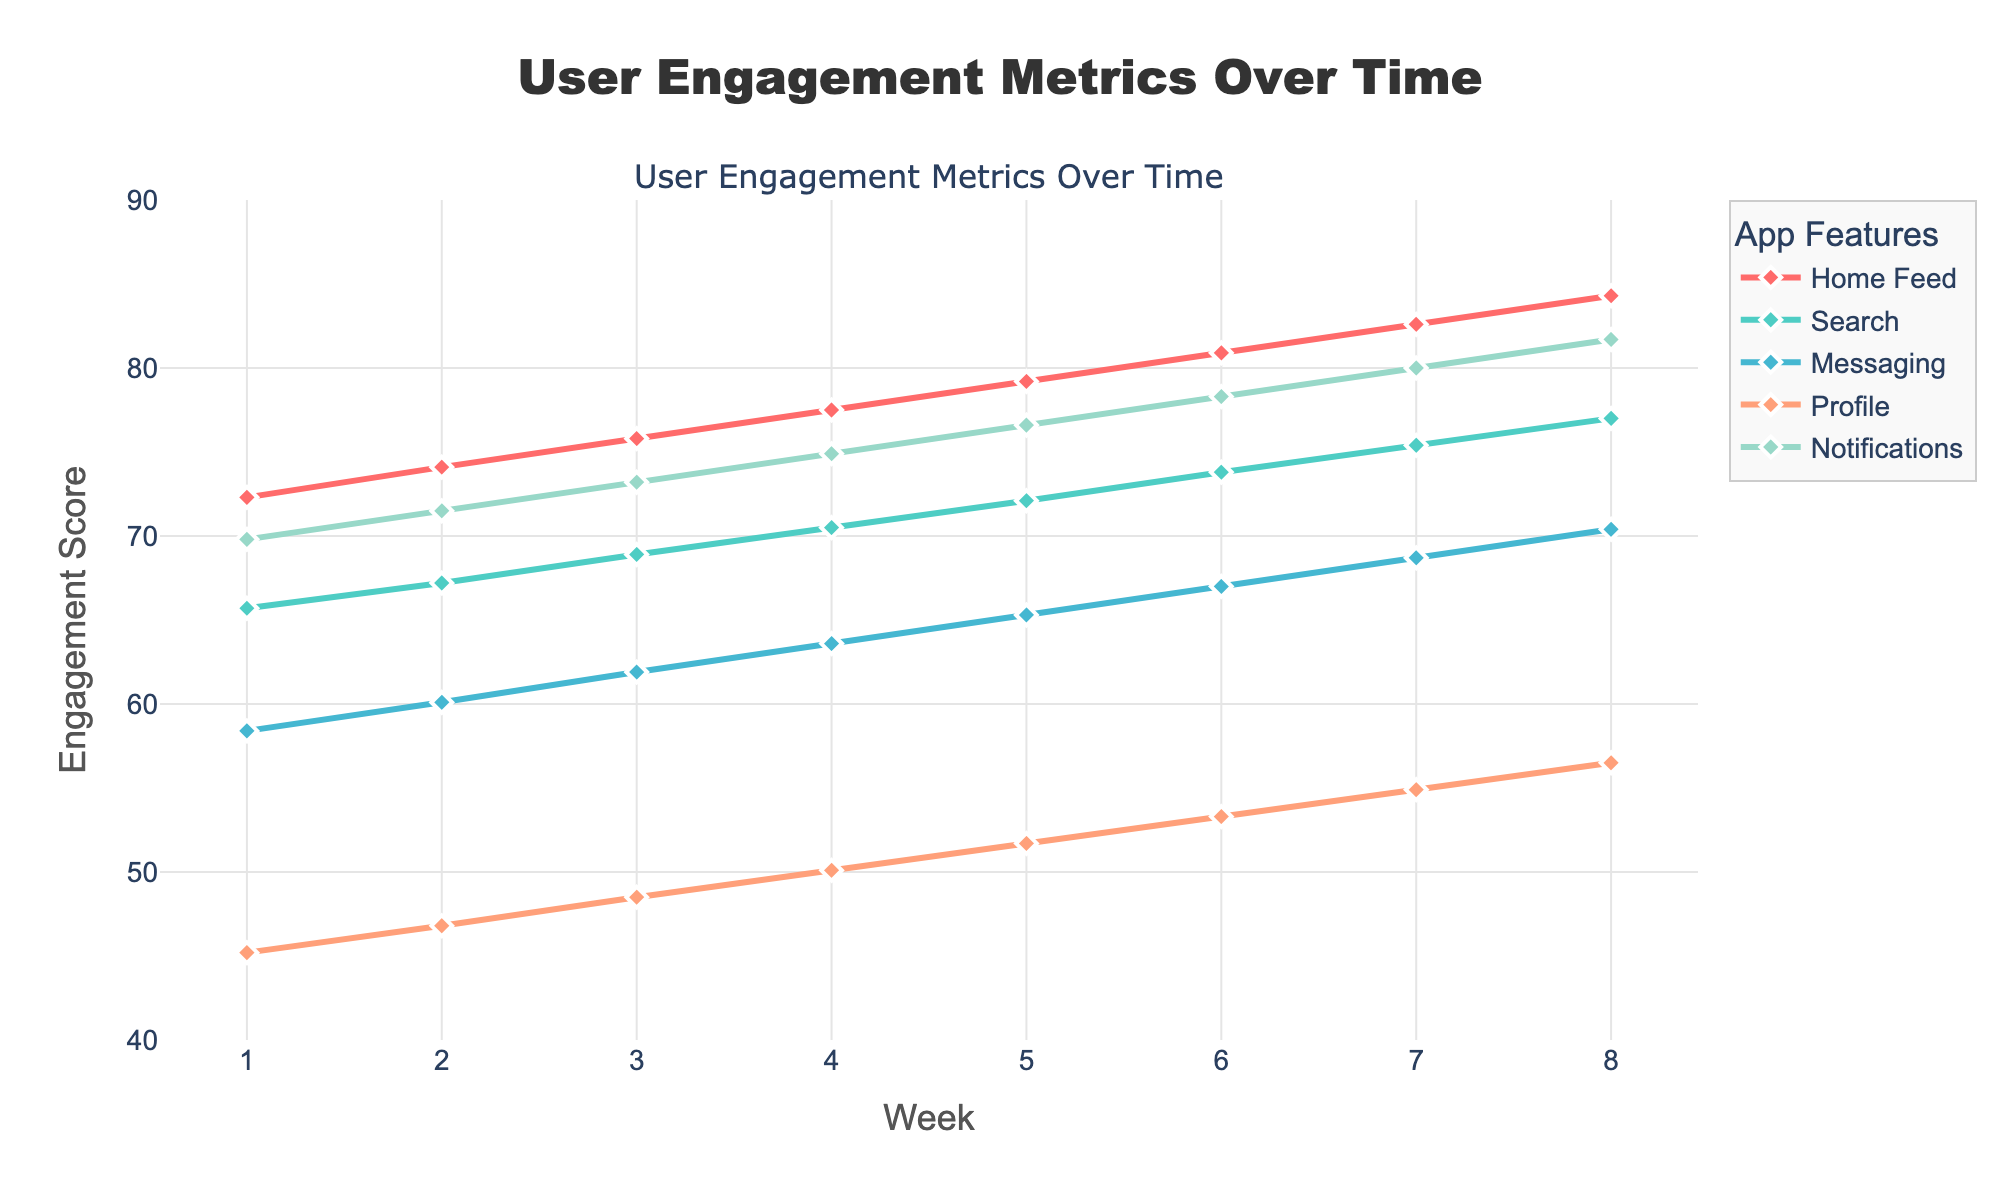Which feature had the highest engagement score at week 4? Locate the engagement scores of all features at week 4: Home Feed (77.5), Search (70.5), Messaging (63.6), Profile (50.1), Notifications (74.9). The highest is 77.5 for Home Feed.
Answer: Home Feed Which feature showed the greatest overall increase in engagement score from week 1 to week 8? Calculate the increase for each feature from week 1 to week 8: Home Feed (84.3 - 72.3 = 12.0), Search (77.0 - 65.7 = 11.3), Messaging (70.4 - 58.4 = 12.0), Profile (56.5 - 45.2 = 11.3), Notifications (81.7-69.8 = 11.9). The greatest increase is for Home Feed and Messaging (12.0).
Answer: Home Feed, Messaging What is the average engagement score for the 'Search' feature over the 8-week period? Sum the engagement scores for Search over the 8 weeks: (65.7 + 67.2 + 68.9 + 70.5 + 72.1 + 73.8 + 75.4 + 77.0) = 570.6. Then, divide by 8 to get the average: 570.6 / 8 = 71.325.
Answer: 71.325 Compare the engagement scores of 'Notifications' and 'Profile' at week 6. Which one had a higher score? Look at the engagement scores at week 6: Notifications (78.3) and Profile (53.3). Compare them to see which one is higher: 78.3 > 53.3.
Answer: Notifications What is the difference in engagement score between 'Messaging' and 'Home Feed' at week 3? Look at the engagement scores for week 3: Home Feed (75.8) and Messaging (61.9). Calculate the difference: 75.8 - 61.9 = 13.9.
Answer: 13.9 Which feature consistently had the lowest engagement score throughout the 8 weeks? Review the engagement scores for each feature across the weeks. Profile feature scores range from 45.2 to 56.5, which is consistently lower than the other features' engagement scores.
Answer: Profile By how much did the engagement score of 'Notifications' increase from week 5 to week 6? Look at the engagement scores for Notifications in week 5 (76.6) and week 6 (78.3). Calculate the difference: 78.3 - 76.6 = 1.7.
Answer: 1.7 